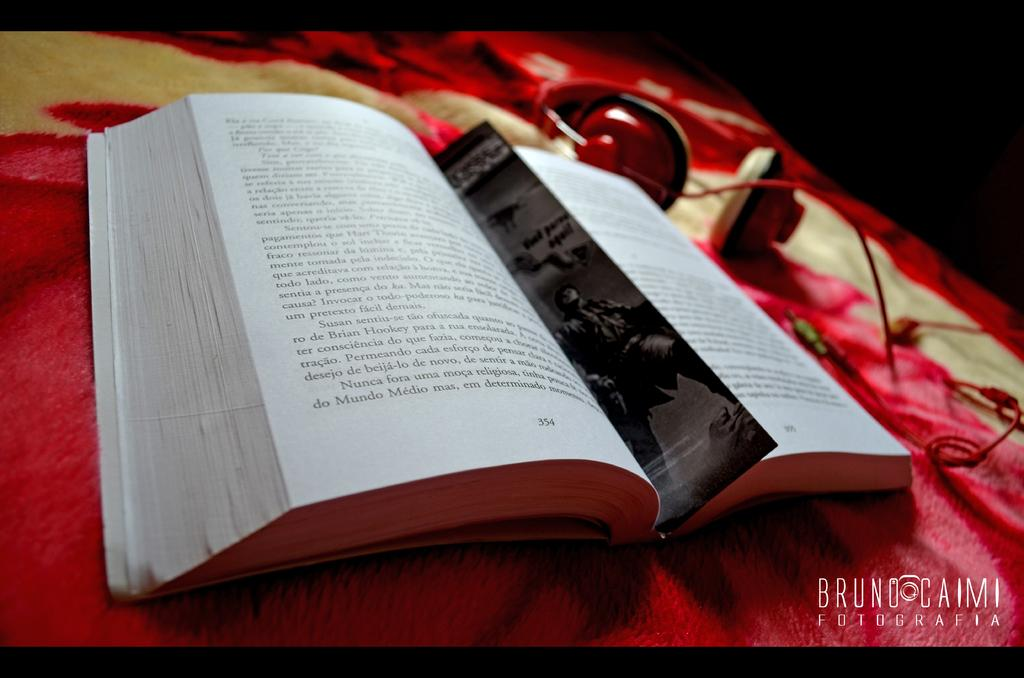Provide a one-sentence caption for the provided image. The water mark on a photo identifies the photographer ad Bruno Caimi. 